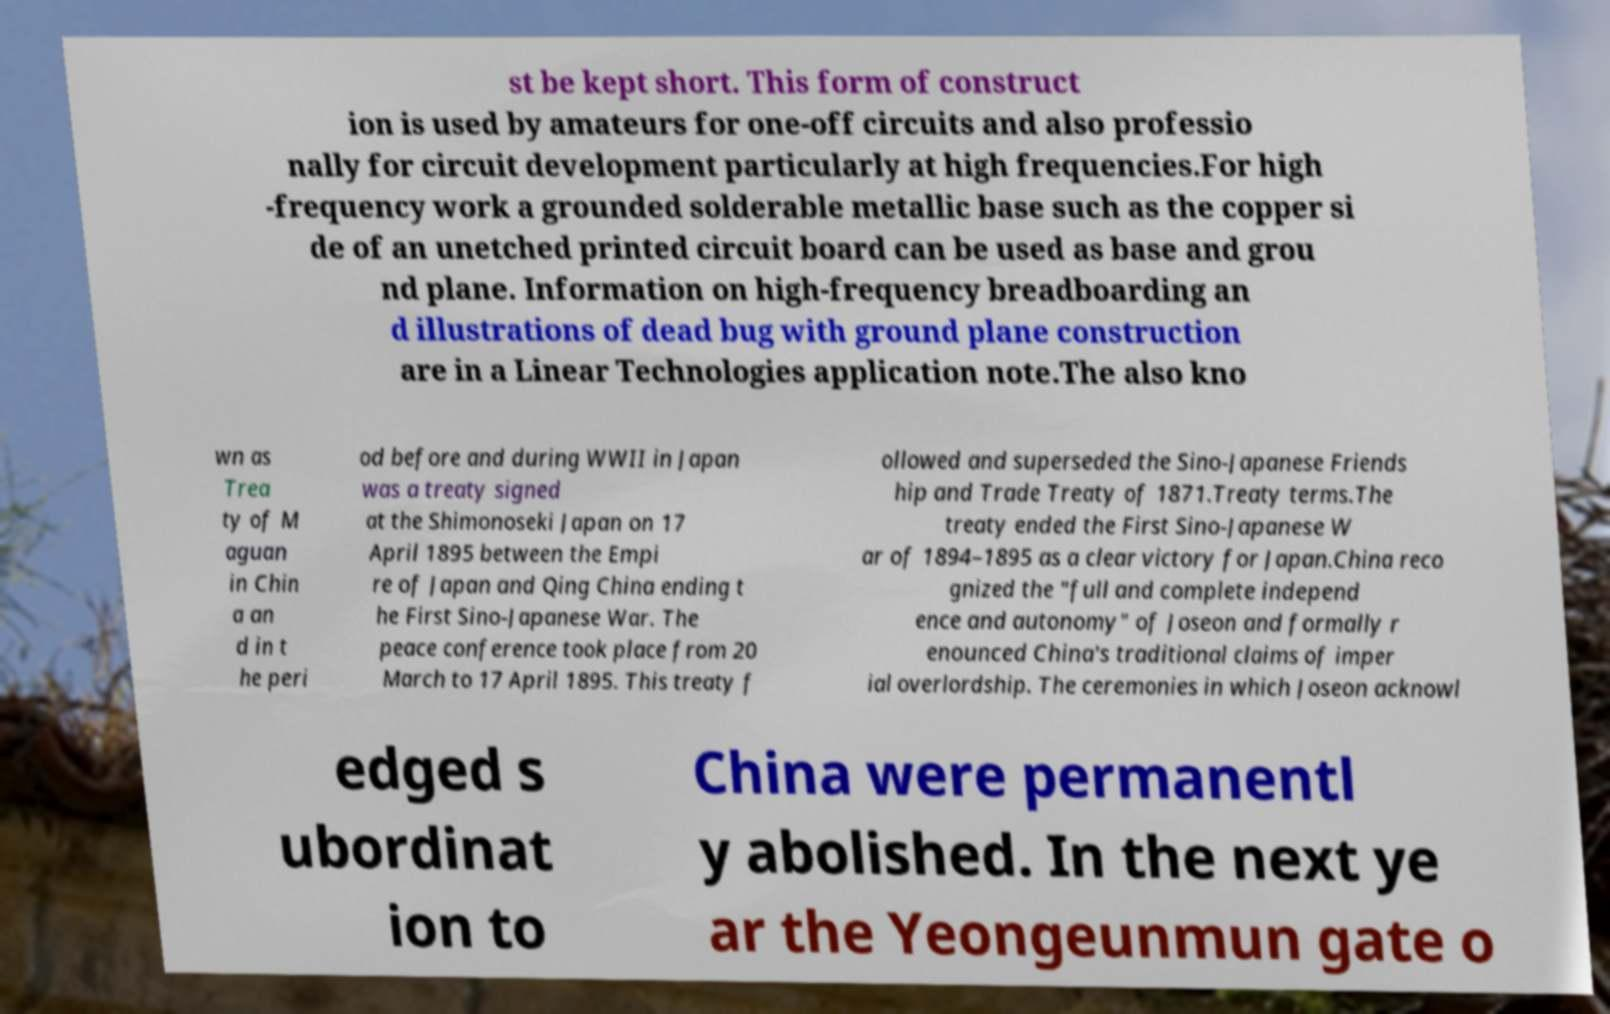For documentation purposes, I need the text within this image transcribed. Could you provide that? st be kept short. This form of construct ion is used by amateurs for one-off circuits and also professio nally for circuit development particularly at high frequencies.For high -frequency work a grounded solderable metallic base such as the copper si de of an unetched printed circuit board can be used as base and grou nd plane. Information on high-frequency breadboarding an d illustrations of dead bug with ground plane construction are in a Linear Technologies application note.The also kno wn as Trea ty of M aguan in Chin a an d in t he peri od before and during WWII in Japan was a treaty signed at the Shimonoseki Japan on 17 April 1895 between the Empi re of Japan and Qing China ending t he First Sino-Japanese War. The peace conference took place from 20 March to 17 April 1895. This treaty f ollowed and superseded the Sino-Japanese Friends hip and Trade Treaty of 1871.Treaty terms.The treaty ended the First Sino-Japanese W ar of 1894–1895 as a clear victory for Japan.China reco gnized the "full and complete independ ence and autonomy" of Joseon and formally r enounced China's traditional claims of imper ial overlordship. The ceremonies in which Joseon acknowl edged s ubordinat ion to China were permanentl y abolished. In the next ye ar the Yeongeunmun gate o 